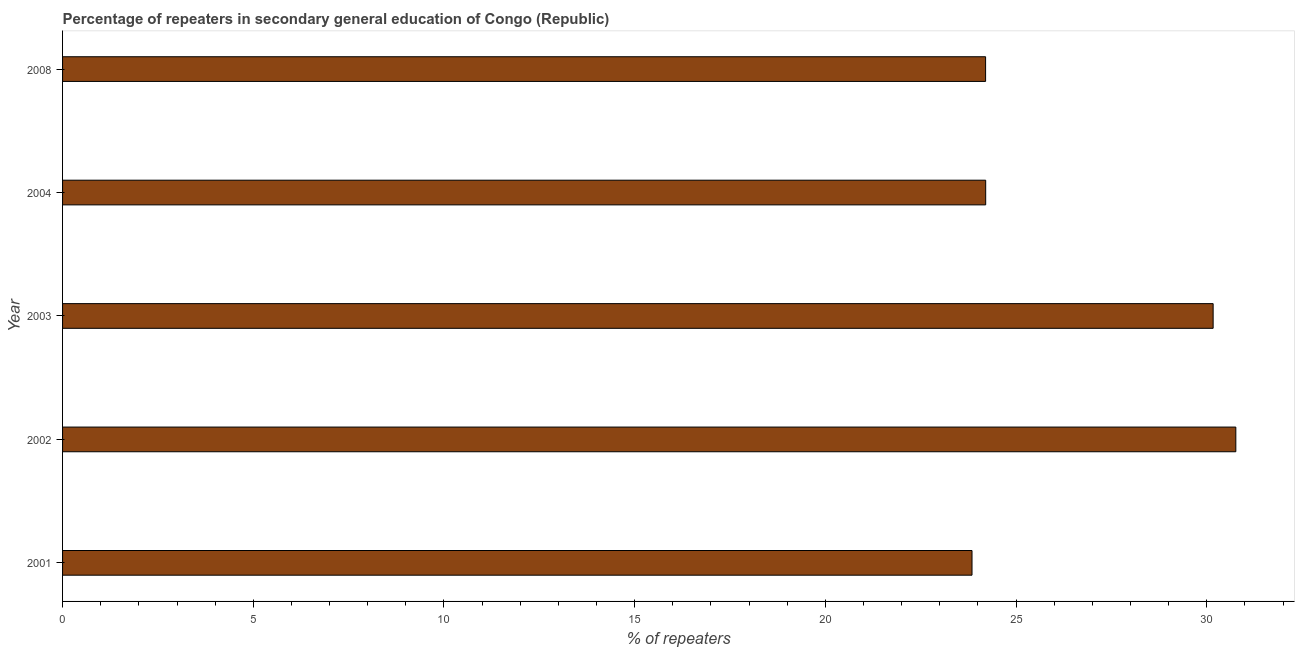Does the graph contain grids?
Your response must be concise. No. What is the title of the graph?
Your response must be concise. Percentage of repeaters in secondary general education of Congo (Republic). What is the label or title of the X-axis?
Ensure brevity in your answer.  % of repeaters. What is the percentage of repeaters in 2002?
Ensure brevity in your answer.  30.76. Across all years, what is the maximum percentage of repeaters?
Provide a short and direct response. 30.76. Across all years, what is the minimum percentage of repeaters?
Your response must be concise. 23.84. What is the sum of the percentage of repeaters?
Provide a succinct answer. 133.17. What is the difference between the percentage of repeaters in 2004 and 2008?
Provide a short and direct response. 0. What is the average percentage of repeaters per year?
Give a very brief answer. 26.63. What is the median percentage of repeaters?
Provide a short and direct response. 24.2. Do a majority of the years between 2003 and 2008 (inclusive) have percentage of repeaters greater than 9 %?
Ensure brevity in your answer.  Yes. What is the ratio of the percentage of repeaters in 2001 to that in 2002?
Provide a short and direct response. 0.78. Is the percentage of repeaters in 2002 less than that in 2008?
Offer a terse response. No. What is the difference between the highest and the second highest percentage of repeaters?
Your response must be concise. 0.59. What is the difference between the highest and the lowest percentage of repeaters?
Your answer should be compact. 6.92. How many bars are there?
Keep it short and to the point. 5. How many years are there in the graph?
Make the answer very short. 5. Are the values on the major ticks of X-axis written in scientific E-notation?
Offer a very short reply. No. What is the % of repeaters in 2001?
Give a very brief answer. 23.84. What is the % of repeaters of 2002?
Offer a terse response. 30.76. What is the % of repeaters in 2003?
Make the answer very short. 30.16. What is the % of repeaters in 2004?
Your answer should be compact. 24.2. What is the % of repeaters of 2008?
Make the answer very short. 24.2. What is the difference between the % of repeaters in 2001 and 2002?
Ensure brevity in your answer.  -6.92. What is the difference between the % of repeaters in 2001 and 2003?
Provide a short and direct response. -6.32. What is the difference between the % of repeaters in 2001 and 2004?
Provide a short and direct response. -0.36. What is the difference between the % of repeaters in 2001 and 2008?
Your response must be concise. -0.36. What is the difference between the % of repeaters in 2002 and 2003?
Give a very brief answer. 0.59. What is the difference between the % of repeaters in 2002 and 2004?
Provide a short and direct response. 6.56. What is the difference between the % of repeaters in 2002 and 2008?
Make the answer very short. 6.56. What is the difference between the % of repeaters in 2003 and 2004?
Your answer should be compact. 5.96. What is the difference between the % of repeaters in 2003 and 2008?
Offer a very short reply. 5.97. What is the difference between the % of repeaters in 2004 and 2008?
Provide a short and direct response. 0. What is the ratio of the % of repeaters in 2001 to that in 2002?
Offer a very short reply. 0.78. What is the ratio of the % of repeaters in 2001 to that in 2003?
Your response must be concise. 0.79. What is the ratio of the % of repeaters in 2001 to that in 2004?
Your answer should be very brief. 0.98. What is the ratio of the % of repeaters in 2002 to that in 2003?
Your answer should be very brief. 1.02. What is the ratio of the % of repeaters in 2002 to that in 2004?
Provide a succinct answer. 1.27. What is the ratio of the % of repeaters in 2002 to that in 2008?
Your response must be concise. 1.27. What is the ratio of the % of repeaters in 2003 to that in 2004?
Make the answer very short. 1.25. What is the ratio of the % of repeaters in 2003 to that in 2008?
Your answer should be compact. 1.25. What is the ratio of the % of repeaters in 2004 to that in 2008?
Offer a very short reply. 1. 